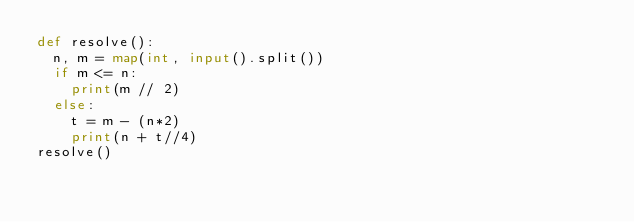<code> <loc_0><loc_0><loc_500><loc_500><_Python_>def resolve():
	n, m = map(int, input().split())
	if m <= n:
		print(m // 2)
	else:
		t = m - (n*2)
		print(n + t//4)
resolve()</code> 